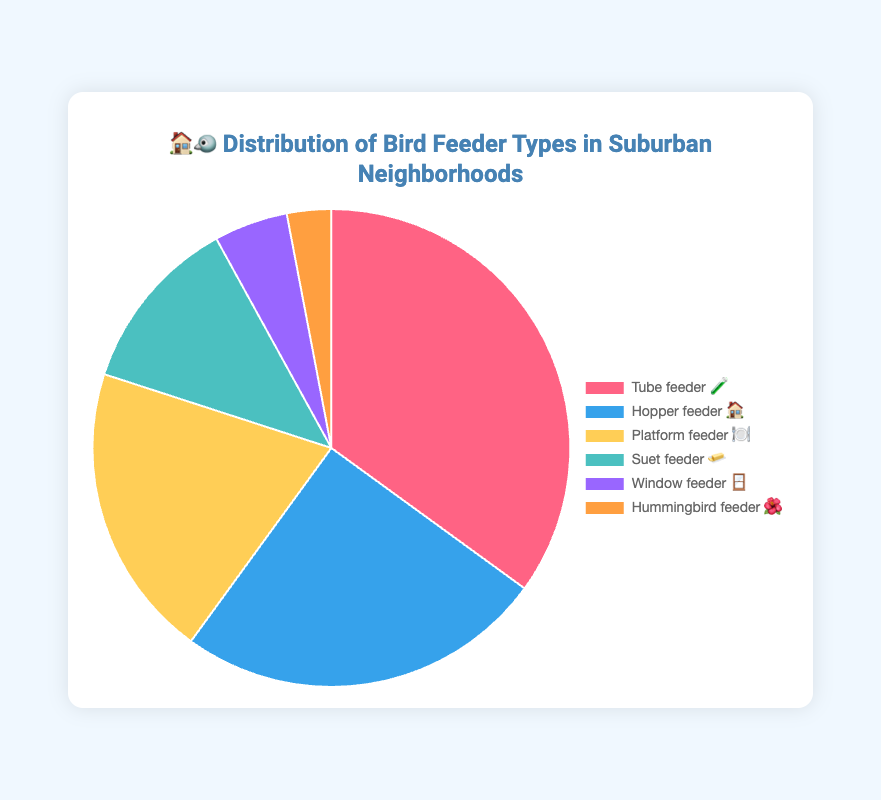What is the most common type of bird feeder in suburban neighborhoods? The chart shows the different types of bird feeders and their percentages. The feeder type with the highest percentage is the most common.
Answer: Tube feeder 🧪 Which bird feeder type represents 25% of the distribution? You need to look at the chart for the feeder type that is labeled with 25%.
Answer: Hopper feeder 🏠 How many bird feeder types have a distribution percentage greater than 20%? Examine all the feeder types and count those with percentages above 20%. Tube feeder 🧪 (35%) and Hopper feeder 🏠 (25%). There are 2 such types.
Answer: 2 What percentage of bird feeders are either Platform feeders 🍽️ or Suet feeders 🧈? Add the percentages of Platform feeders (20%) and Suet feeders (12%).
Answer: 32% Which is more common, Window feeders 🪟 or Hummingbird feeders 🌺, and by how much? Compare the percentages of Window feeders (5%) and Hummingbird feeders (3%). The difference is calculated by subtracting 3% from 5%.
Answer: Window feeders by 2% How does the proportion of Hopper feeders 🏠 compare to that of Platform feeders 🍽️? Compare the percentages of Hopper feeders (25%) and Platform feeders (20%). Hopper feeders have a higher percentage.
Answer: Hopper feeders have a higher percentage than Platform feeders Which feeder has the least representation in the distribution and what percentage does it have? Find the feeder type with the smallest percentage in the chart.
Answer: Hummingbird feeder 🌺, 3% What is the combined percentage of the three least common bird feeders? Add the percentages of the three least common feeders: Suet feeder 🧈 (12%), Window feeder 🪟 (5%), and Hummingbird feeder 🌺 (3%).
Answer: 20% How much more common are Tube feeders 🧪 compared to Suet feeders 🧈? Subtract the percentage of Suet feeders (12%) from the percentage of Tube feeders (35%).
Answer: 23% 